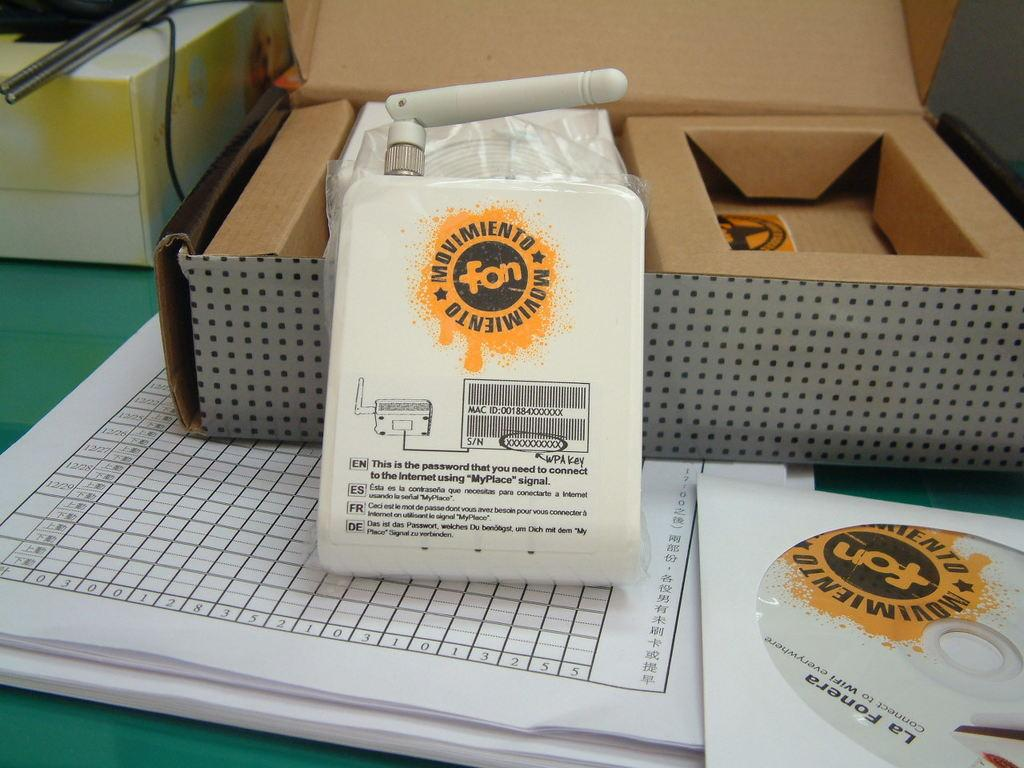What is one of the objects on the table in the image? There is a box in the image. What electronic device is visible in the image? There is a router in the image. What type of disc is present in the image? There is a disc in the image. What type of paper items are on the table in the image? There are papers in the image. How many boxes are on the table in the image? There are two boxes on the table in the image. Can you see any lumber or knots in the image? No, there is no lumber or knots present in the image. How does the router sneeze in the image? Electronic devices like routers do not sneeze, so this question is not applicable to the image. 